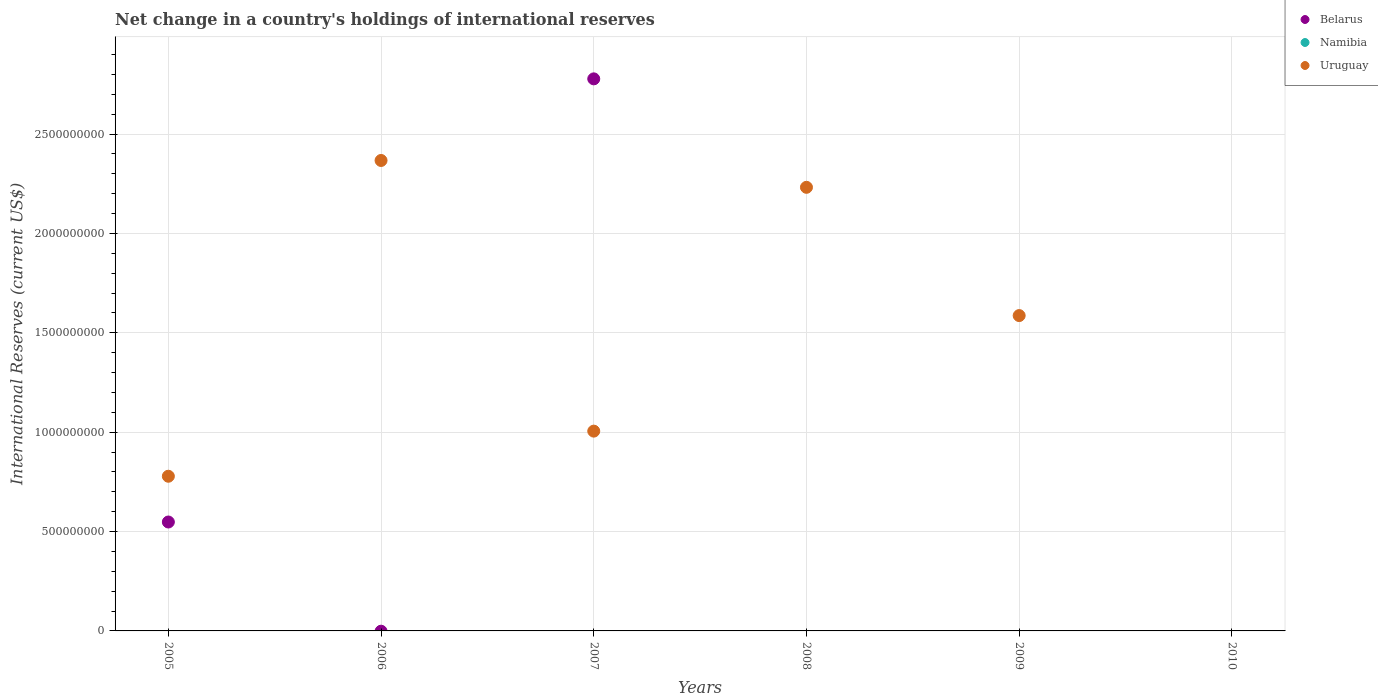What is the international reserves in Uruguay in 2005?
Your response must be concise. 7.78e+08. Across all years, what is the maximum international reserves in Belarus?
Offer a very short reply. 2.78e+09. Across all years, what is the minimum international reserves in Uruguay?
Your answer should be very brief. 0. What is the total international reserves in Namibia in the graph?
Provide a succinct answer. 0. What is the difference between the international reserves in Uruguay in 2006 and that in 2009?
Make the answer very short. 7.81e+08. What is the difference between the international reserves in Uruguay in 2007 and the international reserves in Namibia in 2008?
Ensure brevity in your answer.  1.01e+09. What is the average international reserves in Uruguay per year?
Keep it short and to the point. 1.33e+09. In how many years, is the international reserves in Uruguay greater than 2000000000 US$?
Keep it short and to the point. 2. What is the ratio of the international reserves in Uruguay in 2007 to that in 2009?
Give a very brief answer. 0.63. What is the difference between the highest and the second highest international reserves in Uruguay?
Keep it short and to the point. 1.35e+08. What is the difference between the highest and the lowest international reserves in Uruguay?
Your response must be concise. 2.37e+09. In how many years, is the international reserves in Namibia greater than the average international reserves in Namibia taken over all years?
Your answer should be compact. 0. Is the sum of the international reserves in Belarus in 2005 and 2007 greater than the maximum international reserves in Namibia across all years?
Keep it short and to the point. Yes. Is it the case that in every year, the sum of the international reserves in Uruguay and international reserves in Belarus  is greater than the international reserves in Namibia?
Your answer should be compact. No. Does the international reserves in Namibia monotonically increase over the years?
Keep it short and to the point. No. Is the international reserves in Namibia strictly less than the international reserves in Uruguay over the years?
Make the answer very short. Yes. How many years are there in the graph?
Ensure brevity in your answer.  6. What is the difference between two consecutive major ticks on the Y-axis?
Keep it short and to the point. 5.00e+08. Does the graph contain any zero values?
Make the answer very short. Yes. Does the graph contain grids?
Make the answer very short. Yes. Where does the legend appear in the graph?
Offer a very short reply. Top right. How many legend labels are there?
Ensure brevity in your answer.  3. What is the title of the graph?
Provide a succinct answer. Net change in a country's holdings of international reserves. Does "Denmark" appear as one of the legend labels in the graph?
Provide a succinct answer. No. What is the label or title of the X-axis?
Ensure brevity in your answer.  Years. What is the label or title of the Y-axis?
Offer a very short reply. International Reserves (current US$). What is the International Reserves (current US$) of Belarus in 2005?
Provide a short and direct response. 5.48e+08. What is the International Reserves (current US$) of Namibia in 2005?
Provide a succinct answer. 0. What is the International Reserves (current US$) of Uruguay in 2005?
Provide a succinct answer. 7.78e+08. What is the International Reserves (current US$) in Namibia in 2006?
Provide a short and direct response. 0. What is the International Reserves (current US$) of Uruguay in 2006?
Give a very brief answer. 2.37e+09. What is the International Reserves (current US$) of Belarus in 2007?
Offer a very short reply. 2.78e+09. What is the International Reserves (current US$) of Uruguay in 2007?
Ensure brevity in your answer.  1.01e+09. What is the International Reserves (current US$) in Uruguay in 2008?
Give a very brief answer. 2.23e+09. What is the International Reserves (current US$) of Uruguay in 2009?
Your response must be concise. 1.59e+09. What is the International Reserves (current US$) of Namibia in 2010?
Ensure brevity in your answer.  0. What is the International Reserves (current US$) of Uruguay in 2010?
Offer a very short reply. 0. Across all years, what is the maximum International Reserves (current US$) of Belarus?
Ensure brevity in your answer.  2.78e+09. Across all years, what is the maximum International Reserves (current US$) in Uruguay?
Give a very brief answer. 2.37e+09. Across all years, what is the minimum International Reserves (current US$) in Belarus?
Make the answer very short. 0. What is the total International Reserves (current US$) of Belarus in the graph?
Provide a short and direct response. 3.33e+09. What is the total International Reserves (current US$) in Uruguay in the graph?
Keep it short and to the point. 7.97e+09. What is the difference between the International Reserves (current US$) in Uruguay in 2005 and that in 2006?
Make the answer very short. -1.59e+09. What is the difference between the International Reserves (current US$) of Belarus in 2005 and that in 2007?
Your answer should be very brief. -2.23e+09. What is the difference between the International Reserves (current US$) in Uruguay in 2005 and that in 2007?
Ensure brevity in your answer.  -2.27e+08. What is the difference between the International Reserves (current US$) of Uruguay in 2005 and that in 2008?
Your response must be concise. -1.45e+09. What is the difference between the International Reserves (current US$) of Uruguay in 2005 and that in 2009?
Your answer should be very brief. -8.09e+08. What is the difference between the International Reserves (current US$) of Uruguay in 2006 and that in 2007?
Your response must be concise. 1.36e+09. What is the difference between the International Reserves (current US$) in Uruguay in 2006 and that in 2008?
Your response must be concise. 1.35e+08. What is the difference between the International Reserves (current US$) of Uruguay in 2006 and that in 2009?
Your answer should be very brief. 7.81e+08. What is the difference between the International Reserves (current US$) of Uruguay in 2007 and that in 2008?
Ensure brevity in your answer.  -1.23e+09. What is the difference between the International Reserves (current US$) of Uruguay in 2007 and that in 2009?
Make the answer very short. -5.81e+08. What is the difference between the International Reserves (current US$) of Uruguay in 2008 and that in 2009?
Keep it short and to the point. 6.45e+08. What is the difference between the International Reserves (current US$) in Belarus in 2005 and the International Reserves (current US$) in Uruguay in 2006?
Offer a very short reply. -1.82e+09. What is the difference between the International Reserves (current US$) in Belarus in 2005 and the International Reserves (current US$) in Uruguay in 2007?
Make the answer very short. -4.57e+08. What is the difference between the International Reserves (current US$) in Belarus in 2005 and the International Reserves (current US$) in Uruguay in 2008?
Ensure brevity in your answer.  -1.68e+09. What is the difference between the International Reserves (current US$) of Belarus in 2005 and the International Reserves (current US$) of Uruguay in 2009?
Make the answer very short. -1.04e+09. What is the difference between the International Reserves (current US$) of Belarus in 2007 and the International Reserves (current US$) of Uruguay in 2008?
Provide a succinct answer. 5.46e+08. What is the difference between the International Reserves (current US$) in Belarus in 2007 and the International Reserves (current US$) in Uruguay in 2009?
Provide a short and direct response. 1.19e+09. What is the average International Reserves (current US$) in Belarus per year?
Provide a short and direct response. 5.54e+08. What is the average International Reserves (current US$) in Uruguay per year?
Offer a terse response. 1.33e+09. In the year 2005, what is the difference between the International Reserves (current US$) of Belarus and International Reserves (current US$) of Uruguay?
Provide a short and direct response. -2.30e+08. In the year 2007, what is the difference between the International Reserves (current US$) of Belarus and International Reserves (current US$) of Uruguay?
Your response must be concise. 1.77e+09. What is the ratio of the International Reserves (current US$) of Uruguay in 2005 to that in 2006?
Your answer should be very brief. 0.33. What is the ratio of the International Reserves (current US$) in Belarus in 2005 to that in 2007?
Offer a terse response. 0.2. What is the ratio of the International Reserves (current US$) of Uruguay in 2005 to that in 2007?
Make the answer very short. 0.77. What is the ratio of the International Reserves (current US$) of Uruguay in 2005 to that in 2008?
Provide a succinct answer. 0.35. What is the ratio of the International Reserves (current US$) of Uruguay in 2005 to that in 2009?
Ensure brevity in your answer.  0.49. What is the ratio of the International Reserves (current US$) of Uruguay in 2006 to that in 2007?
Make the answer very short. 2.35. What is the ratio of the International Reserves (current US$) of Uruguay in 2006 to that in 2008?
Ensure brevity in your answer.  1.06. What is the ratio of the International Reserves (current US$) in Uruguay in 2006 to that in 2009?
Offer a terse response. 1.49. What is the ratio of the International Reserves (current US$) in Uruguay in 2007 to that in 2008?
Keep it short and to the point. 0.45. What is the ratio of the International Reserves (current US$) of Uruguay in 2007 to that in 2009?
Provide a succinct answer. 0.63. What is the ratio of the International Reserves (current US$) of Uruguay in 2008 to that in 2009?
Your answer should be very brief. 1.41. What is the difference between the highest and the second highest International Reserves (current US$) in Uruguay?
Your answer should be very brief. 1.35e+08. What is the difference between the highest and the lowest International Reserves (current US$) of Belarus?
Your answer should be very brief. 2.78e+09. What is the difference between the highest and the lowest International Reserves (current US$) of Uruguay?
Provide a short and direct response. 2.37e+09. 